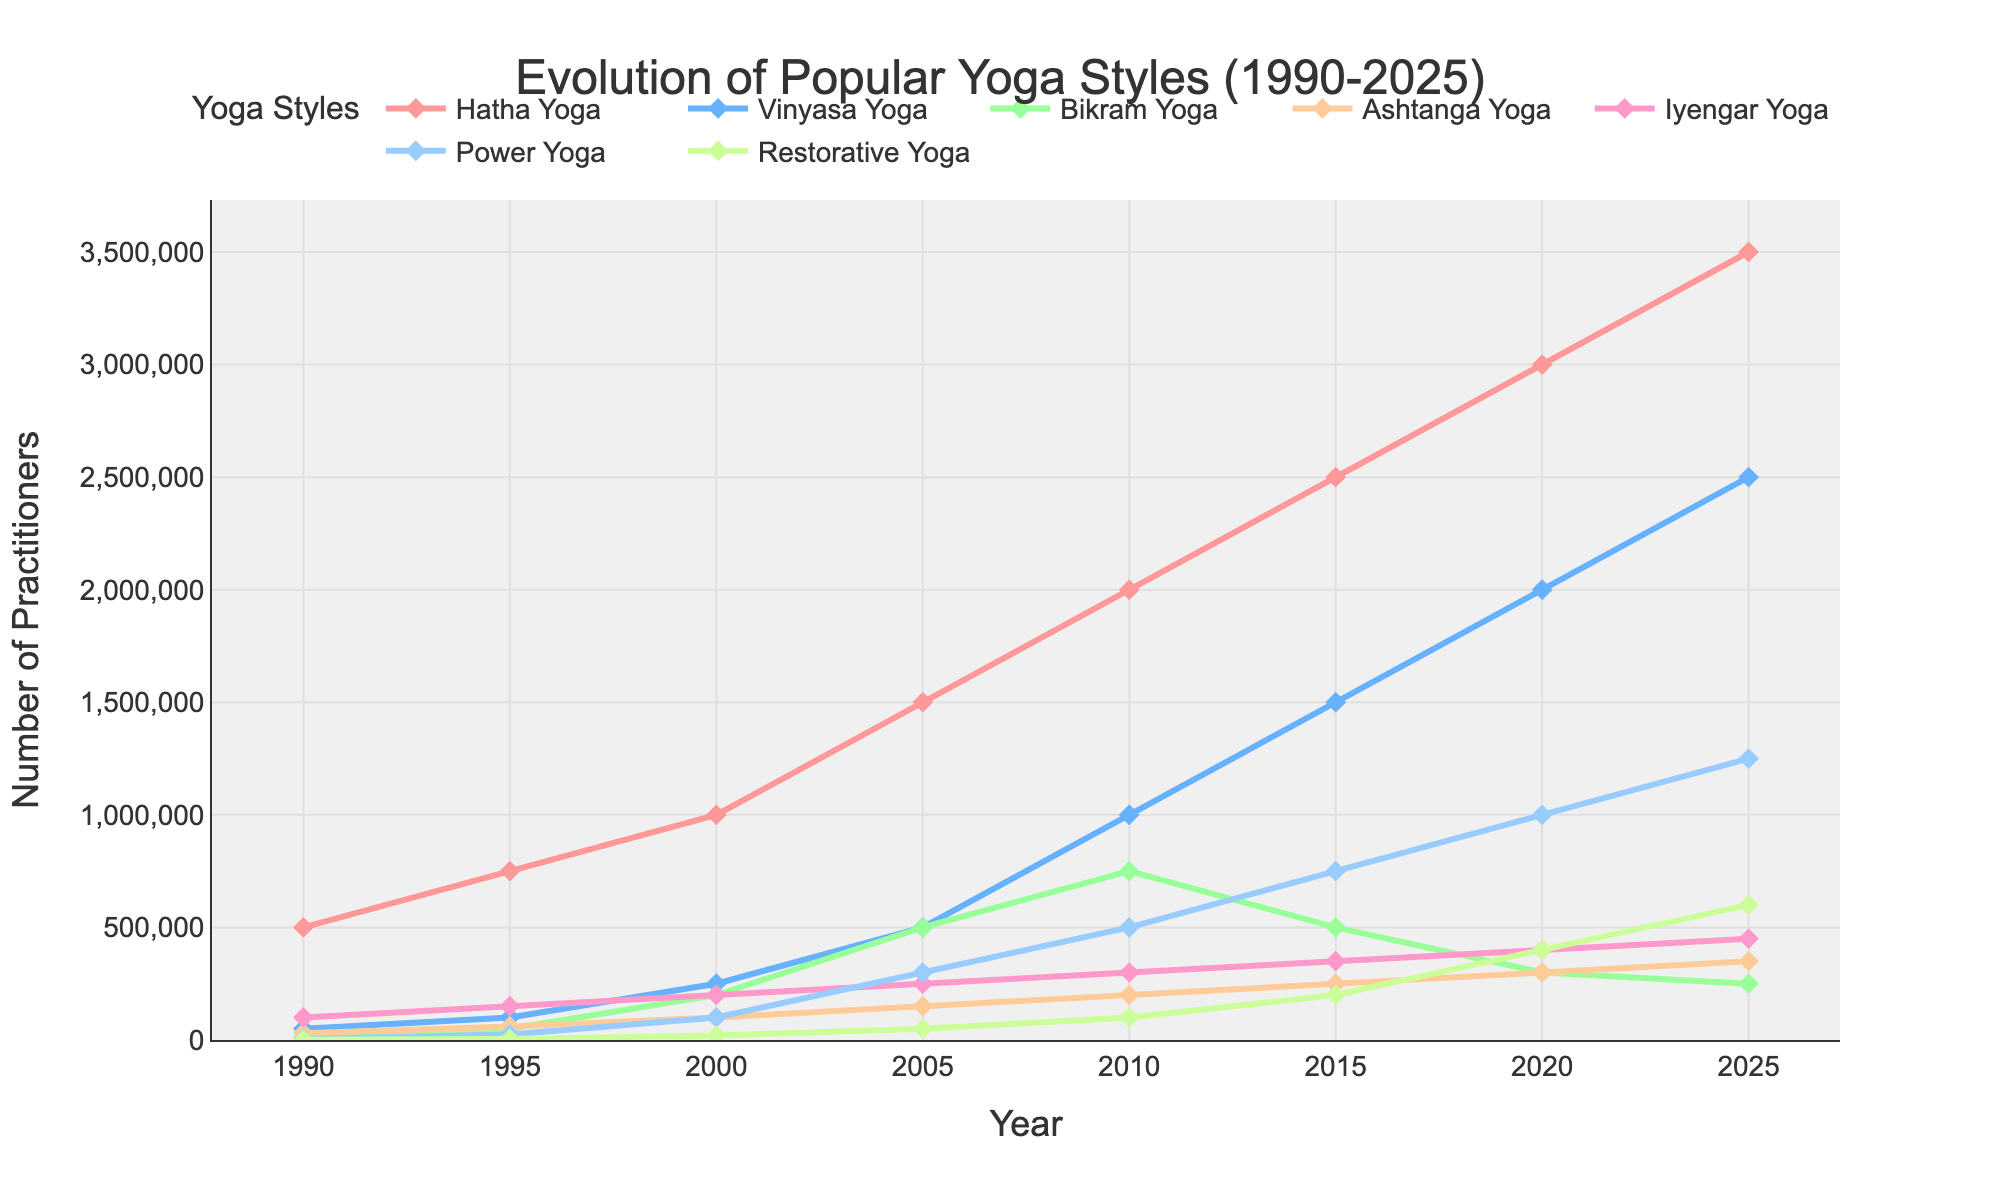What yoga style had the highest number of practitioners in 2025? Looking at the far-right side of the line chart, identify the line that reaches the highest point. Hatha Yoga has the highest number of practitioners in 2025.
Answer: Hatha Yoga Which two yoga styles had the same number of practitioners in 2000? Find the year 2000 on the x-axis and check the y-values for all yoga styles. Vinyasa Yoga and Iyengar Yoga both had 200,000 practitioners in 2000.
Answer: Vinyasa Yoga and Iyengar Yoga By how much did the number of practitioners of Restorative Yoga increase from 1990 to 2020? Subtract the number of practitioners in 1990 from the number in 2020. (400,000 - 1,000) = 399,000.
Answer: 399,000 Which yoga style had the most significant growth in practitioners between 1990 and 2025? By examining the starting and ending points of each line, Hatha Yoga starts at 500,000 in 1990 and grows to 3,500,000 in 2025, indicating the most significant growth.
Answer: Hatha Yoga In what year did Bikram Yoga have its peak number of practitioners? Notice the peak point in the Bikram Yoga line; it peaks at 2005 with 500,000 practitioners.
Answer: 2005 What is the combined number of practitioners for Hatha Yoga and Power Yoga in 2010? Add the number of practitioners for Hatha Yoga (2,000,000) and Power Yoga (500,000) in 2010: (2,000,000 + 500,000) = 2,500,000.
Answer: 2,500,000 Which yoga style exhibited a steady increase in the number of practitioners without any decline across the years displayed? Check each line for consistent upward trajectories. Hatha Yoga shows a steady increase without any declines.
Answer: Hatha Yoga Compare the number of practitioners of Ashtanga Yoga in 1995 and 2015. How does one number relate to the other? Compare the y-values for Ashtanga Yoga in both years: 60,000 in 1995 and 250,000 in 2015. The number in 2015 is greater than the number in 1995 by 190,000.
Answer: Greater by 190,000 